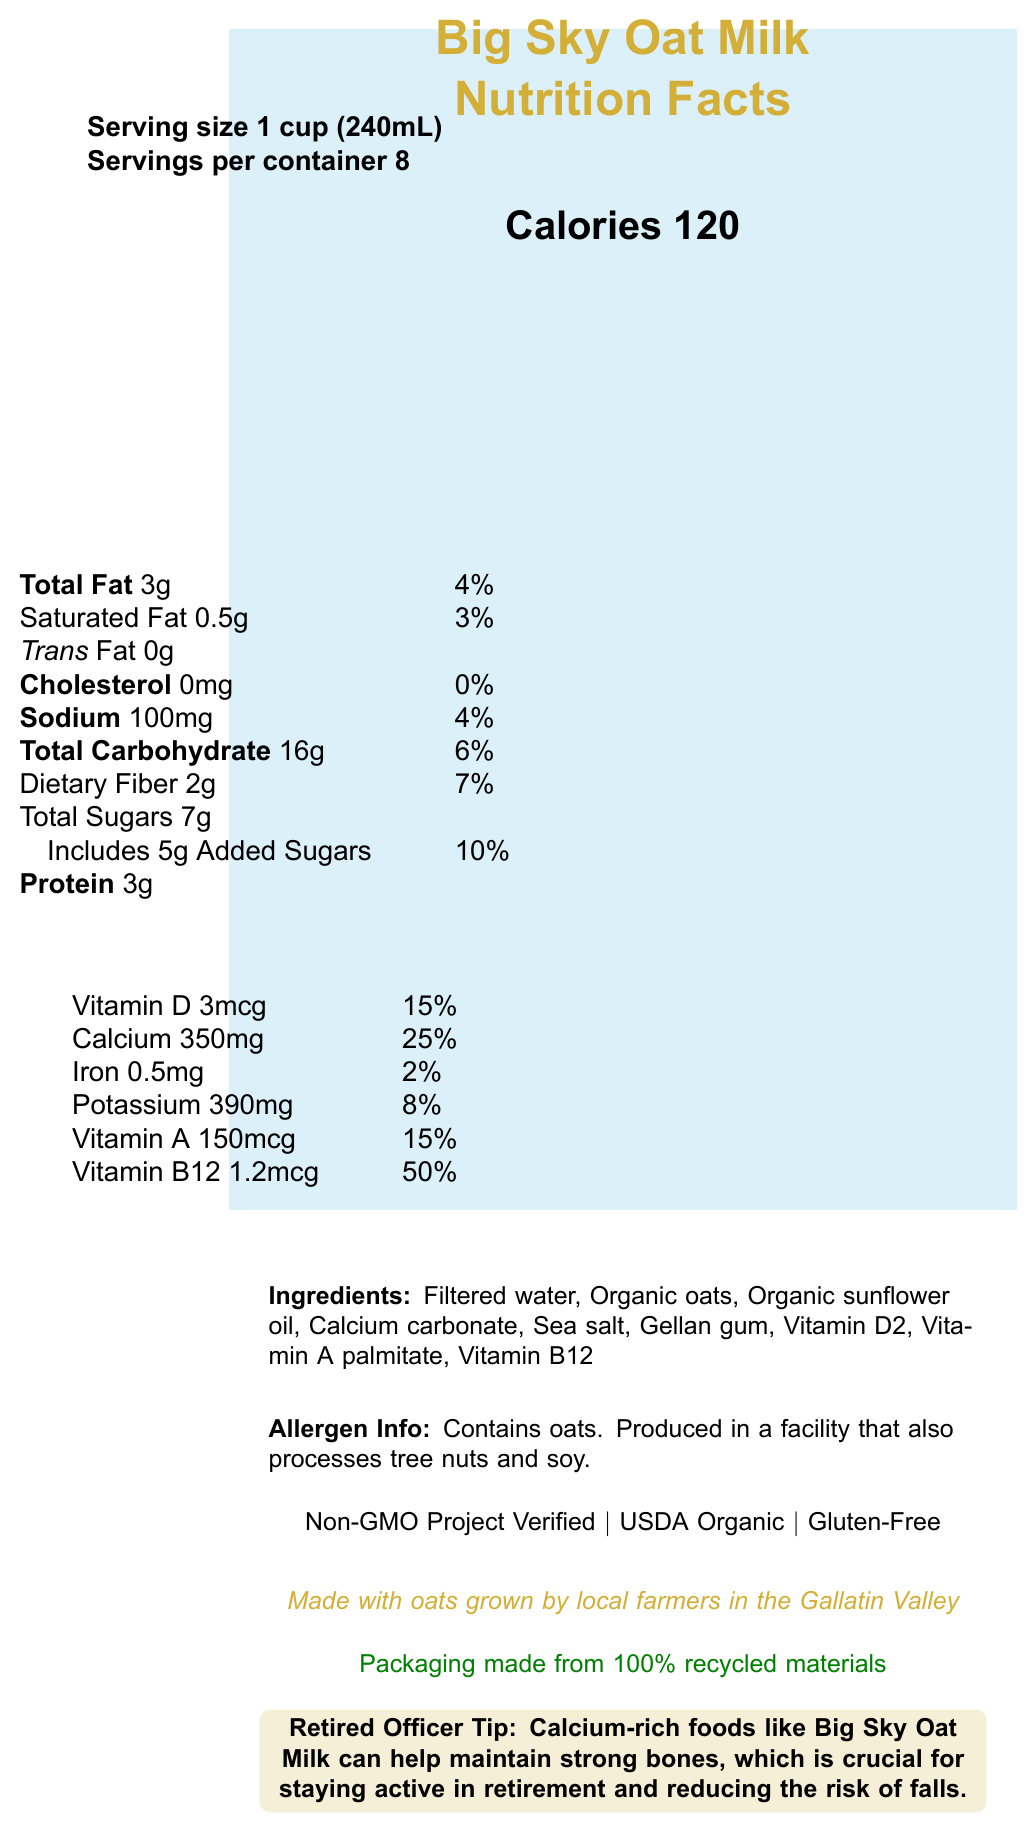what is the serving size for Big Sky Oat Milk? The serving size is mentioned at the top of the nutrition facts label.
Answer: 1 cup (240mL) how many calories are in one serving of Big Sky Oat Milk? The calorie count for one serving is clearly stated in the document.
Answer: 120 how much calcium does one serving contain? The amount of calcium per serving is listed in the vitamin and mineral information section.
Answer: 350mg what is the daily value percentage of added sugars in one serving? The daily value percentage for added sugars is provided next to the added sugars amount.
Answer: 10% is Big Sky Oat Milk gluten-free? The document lists that the product is certified gluten-free.
Answer: Yes which vitamins or minerals have a daily value percentage of 15%? Both Vitamin D and Vitamin A have a daily value percentage of 15%.
Answer: Vitamin D and Vitamin A what are the main ingredients of Big Sky Oat Milk? The ingredients list is provided in the document.
Answer: Filtered water, Organic oats, Organic sunflower oil, Calcium carbonate, Sea salt, Gellan gum, Vitamin D2, Vitamin A palmitate, Vitamin B12 how many servings are there per container of Big Sky Oat Milk? A. 6 B. 8 C. 10 D. 12 The servings per container is indicated as 8.
Answer: B what is the sodium content in one serving of Big Sky Oat Milk? A. 50mg B. 100mg C. 150mg D. 200mg The sodium content is listed as 100mg per serving.
Answer: B does Big Sky Oat Milk contain cholesterol? The nutrition facts state that cholesterol content is 0mg.
Answer: No is the packaging of Big Sky Oat Milk made from 100% recycled materials? The sustainability note mentions that the packaging is made from 100% recycled materials.
Answer: Yes what certifications does Big Sky Oat Milk have? These certifications are listed towards the bottom of the document.
Answer: Non-GMO Project Verified, USDA Organic, Gluten-Free describe the main idea of the document. The document aims to inform customers about the nutritional value, ingredients, and certifications of the product while emphasizing its local and sustainable aspects.
Answer: The document provides the nutrition facts for Big Sky Oat Milk, a calcium-rich dairy alternative made from Montana-grown oats, including calorie content, vitamin and mineral information, ingredients, allergen info, certifications, and a note about its sustainability and local production. how much protein is in one serving of Big Sky Oat Milk? The protein content per serving is stated in the nutrition facts.
Answer: 3g what is the percentage daily value of potassium in one serving? The document lists the daily value percentage of potassium as 8%.
Answer: 8% what is the amount of iron in one serving of Big Sky Oat Milk? The iron content per serving is listed alongside other vitamins and minerals.
Answer: 0.5mg how many grams of dietary fiber are in one serving? The dietary fiber content is part of the total carbohydrate section in the nutrition facts.
Answer: 2g how many grams of total carbohydrates are in one serving? The total carbohydrate content is listed in the nutrition facts.
Answer: 16g what is the suggested benefit of Big Sky Oat Milk for retired officers? This tip is specifically highlighted in the document.
Answer: Calcium-rich foods like Big Sky Oat Milk can help maintain strong bones, which is crucial for staying active in retirement and reducing the risk of falls. who are the local producers of oats used in Big Sky Oat Milk? The document mentions that the oats are grown by local farmers in the Gallatin Valley but does not specify the names of the producers.
Answer: Not enough information 